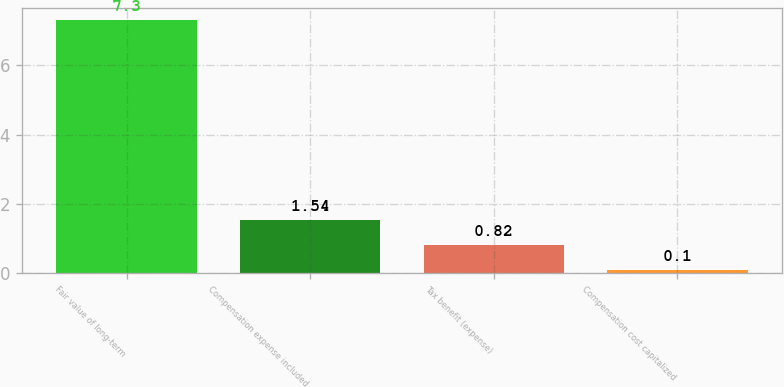Convert chart. <chart><loc_0><loc_0><loc_500><loc_500><bar_chart><fcel>Fair value of long-term<fcel>Compensation expense included<fcel>Tax benefit (expense)<fcel>Compensation cost capitalized<nl><fcel>7.3<fcel>1.54<fcel>0.82<fcel>0.1<nl></chart> 